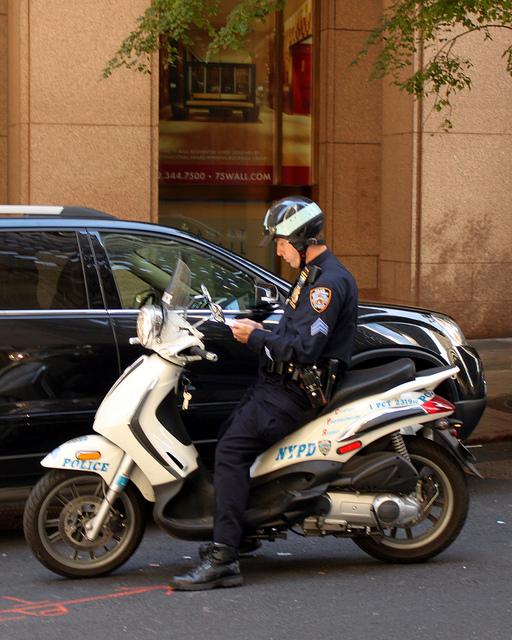What is he doing?
Give a very brief answer. Writing ticket. Is the officer writing a ticket?
Write a very short answer. Yes. Is the motorcycle static or kinetic?
Keep it brief. Static. What color is the car in the background?
Be succinct. Black. What kind of vehicle is this?
Be succinct. Motorcycle. What is the police doing?
Keep it brief. Writing ticket. 